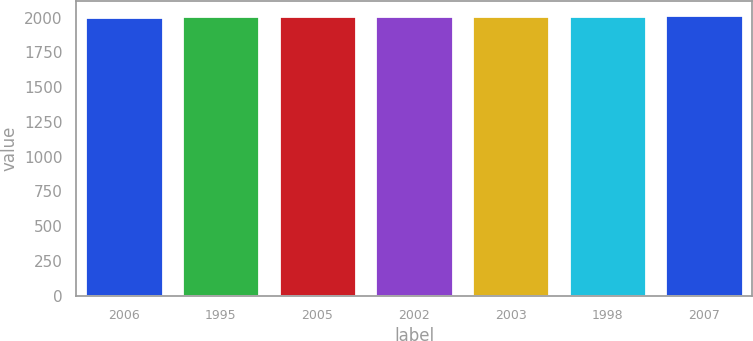Convert chart. <chart><loc_0><loc_0><loc_500><loc_500><bar_chart><fcel>2006<fcel>1995<fcel>2005<fcel>2002<fcel>2003<fcel>1998<fcel>2007<nl><fcel>2008<fcel>2010<fcel>2010.9<fcel>2012<fcel>2015<fcel>2015.9<fcel>2017<nl></chart> 